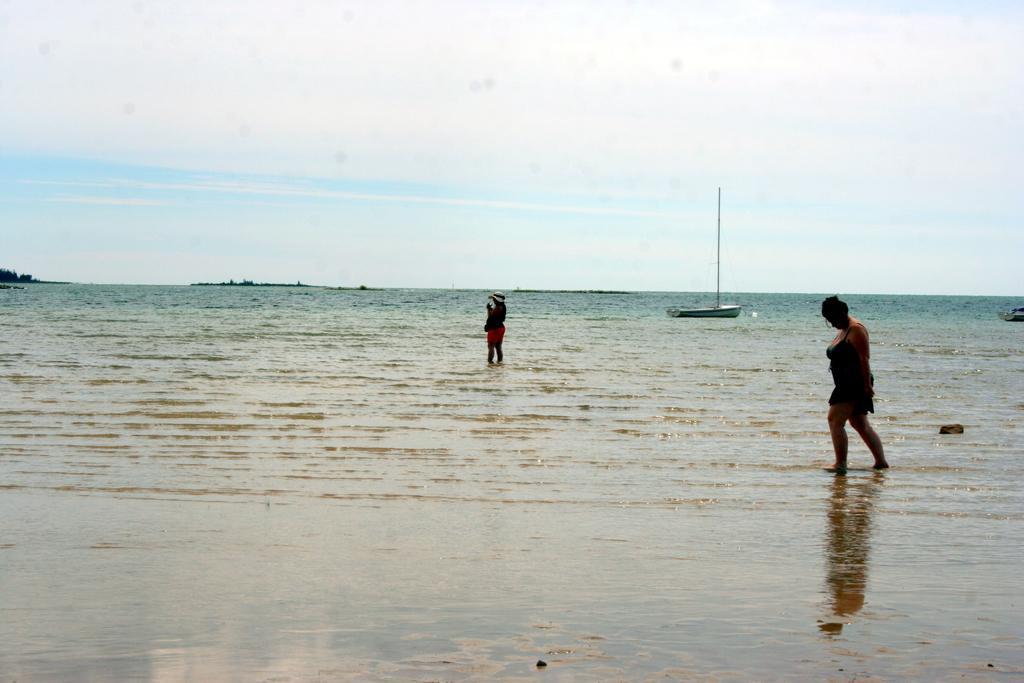In one or two sentences, can you explain what this image depicts? In this image we can see two persons standing in water. In the background, we can see a boat with a pole, mountain and the sky. 